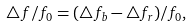Convert formula to latex. <formula><loc_0><loc_0><loc_500><loc_500>\bigtriangleup f / f _ { 0 } = ( \bigtriangleup f _ { b } - \bigtriangleup f _ { r } ) / f _ { 0 } ,</formula> 